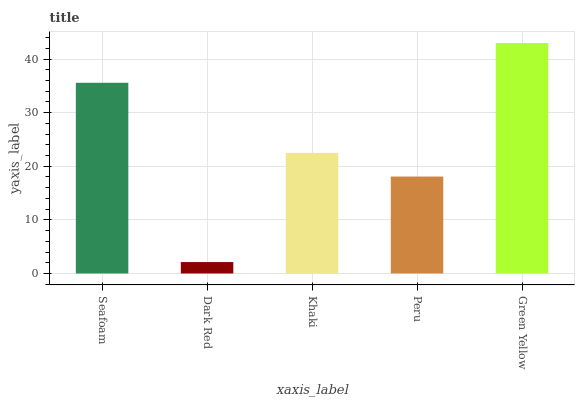Is Dark Red the minimum?
Answer yes or no. Yes. Is Green Yellow the maximum?
Answer yes or no. Yes. Is Khaki the minimum?
Answer yes or no. No. Is Khaki the maximum?
Answer yes or no. No. Is Khaki greater than Dark Red?
Answer yes or no. Yes. Is Dark Red less than Khaki?
Answer yes or no. Yes. Is Dark Red greater than Khaki?
Answer yes or no. No. Is Khaki less than Dark Red?
Answer yes or no. No. Is Khaki the high median?
Answer yes or no. Yes. Is Khaki the low median?
Answer yes or no. Yes. Is Dark Red the high median?
Answer yes or no. No. Is Seafoam the low median?
Answer yes or no. No. 